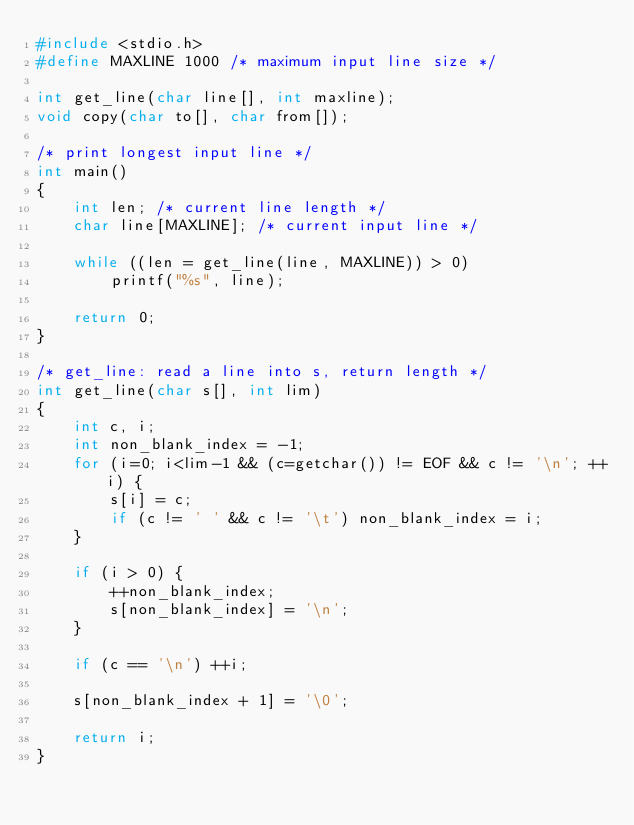Convert code to text. <code><loc_0><loc_0><loc_500><loc_500><_C_>#include <stdio.h>
#define MAXLINE 1000 /* maximum input line size */

int get_line(char line[], int maxline);
void copy(char to[], char from[]);

/* print longest input line */
int main()
{
	int len; /* current line length */
	char line[MAXLINE]; /* current input line */

	while ((len = get_line(line, MAXLINE)) > 0)
		printf("%s", line);

	return 0;
}

/* get_line: read a line into s, return length */
int get_line(char s[], int lim)
{
	int c, i;
	int non_blank_index = -1;
	for (i=0; i<lim-1 && (c=getchar()) != EOF && c != '\n'; ++i) {
		s[i] = c;
		if (c != ' ' && c != '\t') non_blank_index = i;
	}
	
	if (i > 0) {
		++non_blank_index;
		s[non_blank_index] = '\n';
	}

	if (c == '\n') ++i;
	
	s[non_blank_index + 1] = '\0';

	return i;
}

</code> 